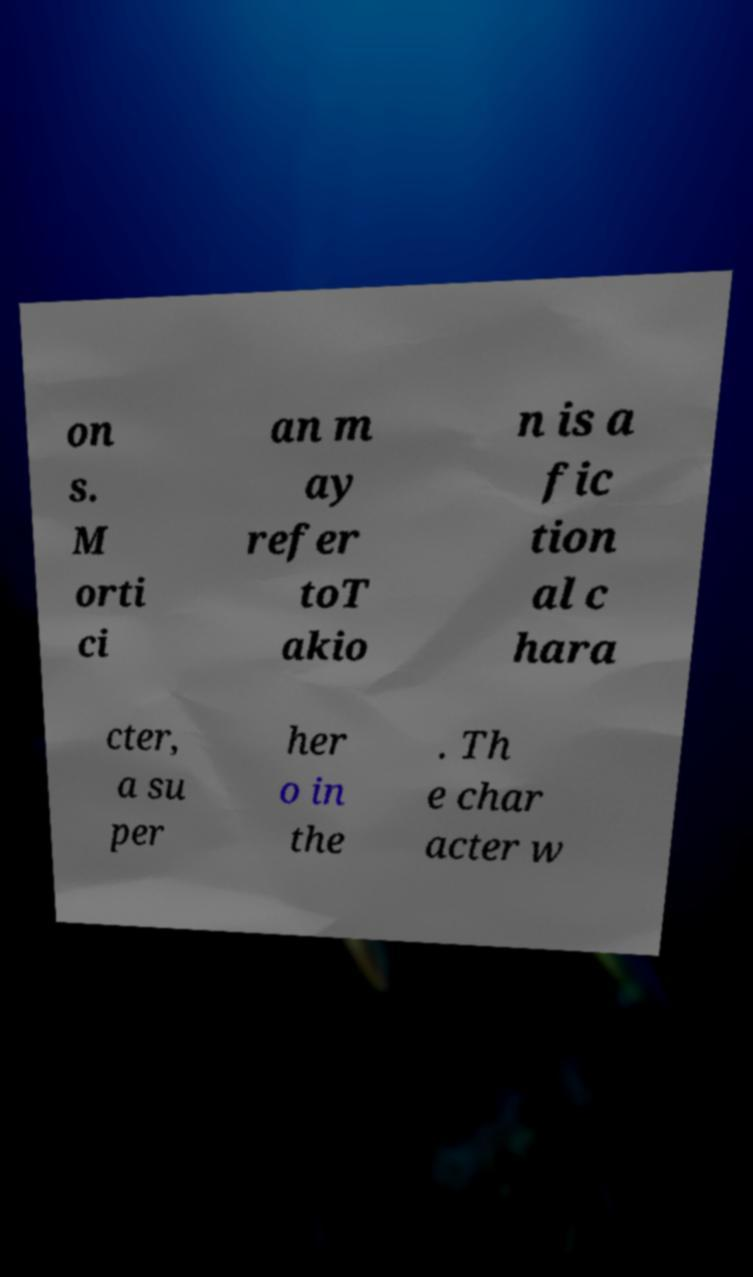What messages or text are displayed in this image? I need them in a readable, typed format. on s. M orti ci an m ay refer toT akio n is a fic tion al c hara cter, a su per her o in the . Th e char acter w 